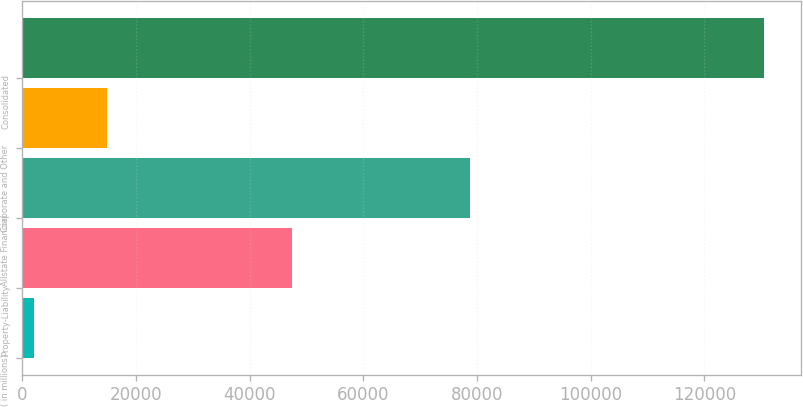Convert chart to OTSL. <chart><loc_0><loc_0><loc_500><loc_500><bar_chart><fcel>( in millions)<fcel>Property-Liability<fcel>Allstate Financial<fcel>Corporate and Other<fcel>Consolidated<nl><fcel>2010<fcel>47536<fcel>78732<fcel>14859<fcel>130500<nl></chart> 